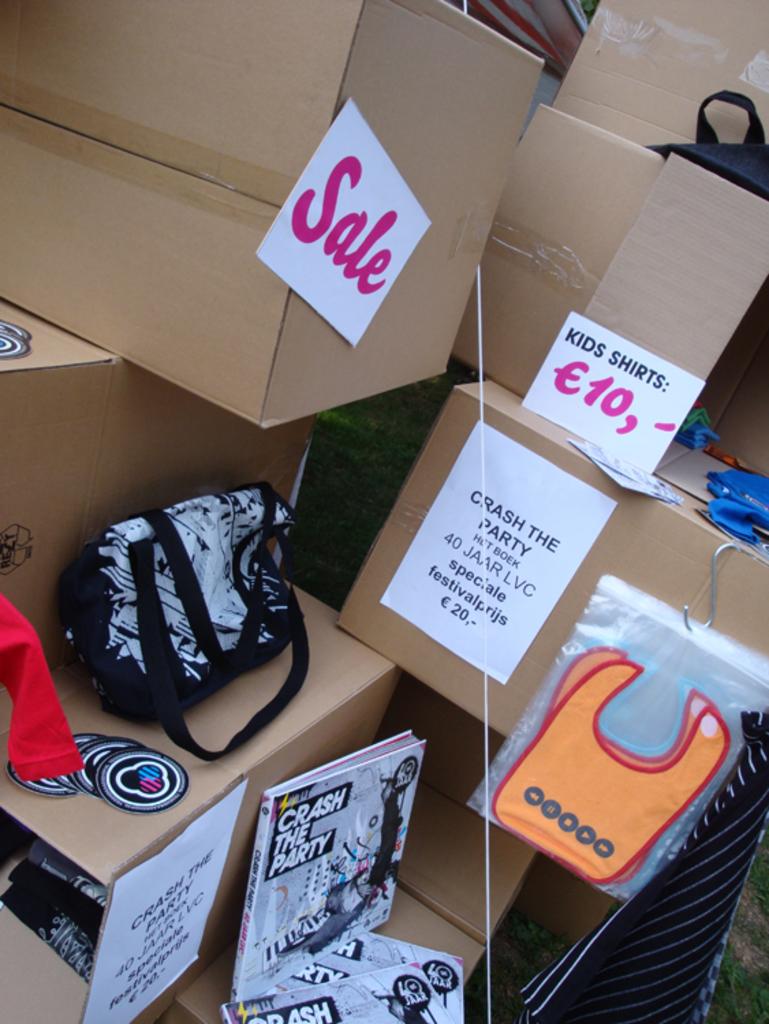How much do the kids shirts cost?
Your answer should be very brief. 10. What is the book suggesting we do?
Provide a succinct answer. Crash the party. 